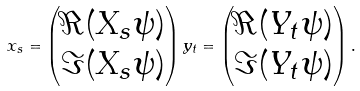<formula> <loc_0><loc_0><loc_500><loc_500>x _ { s } = \begin{pmatrix} \Re ( X _ { s } \psi ) \\ \Im ( X _ { s } \psi ) \end{pmatrix} y _ { t } = \begin{pmatrix} \Re ( Y _ { t } \psi ) \\ \Im ( Y _ { t } \psi ) \end{pmatrix} .</formula> 